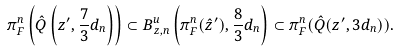<formula> <loc_0><loc_0><loc_500><loc_500>\pi ^ { n } _ { F } \left ( \hat { Q } \left ( z ^ { \prime } , \frac { 7 } { 3 } d _ { n } \right ) \right ) \subset B ^ { u } _ { z , n } \left ( \pi ^ { n } _ { F } ( \hat { z } ^ { \prime } ) , \frac { 8 } { 3 } d _ { n } \right ) \subset \pi ^ { n } _ { F } ( \hat { Q } ( z ^ { \prime } , 3 d _ { n } ) ) .</formula> 